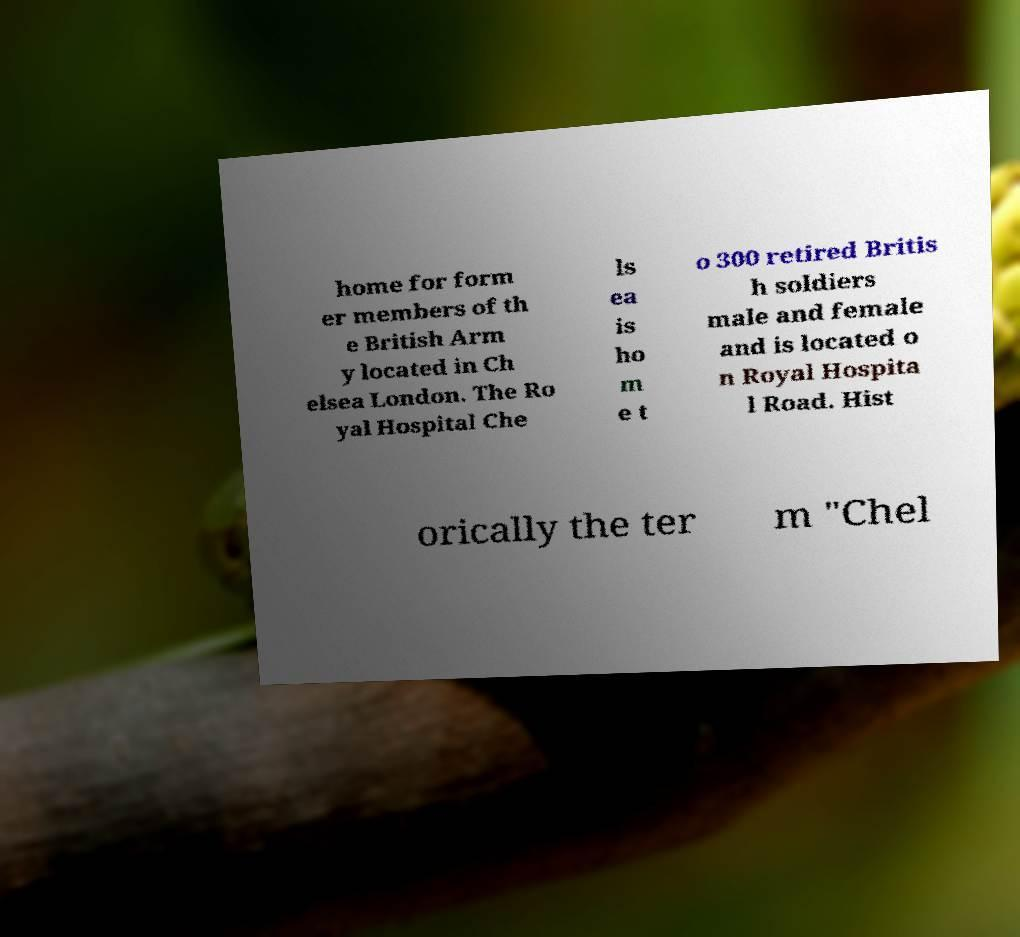Please read and relay the text visible in this image. What does it say? home for form er members of th e British Arm y located in Ch elsea London. The Ro yal Hospital Che ls ea is ho m e t o 300 retired Britis h soldiers male and female and is located o n Royal Hospita l Road. Hist orically the ter m "Chel 